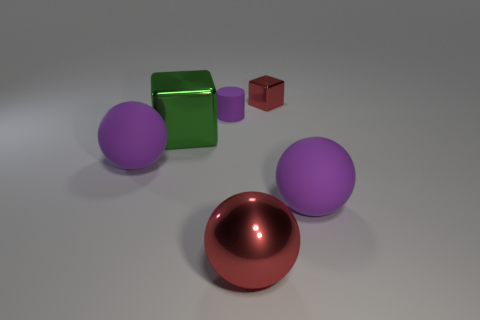How many objects are large green objects or purple matte balls that are right of the tiny metal cube? There is one large green object, which is a cube, and one purple matte ball situated to the right of the tiny metal cube, making a total of two objects that meet the criteria. 